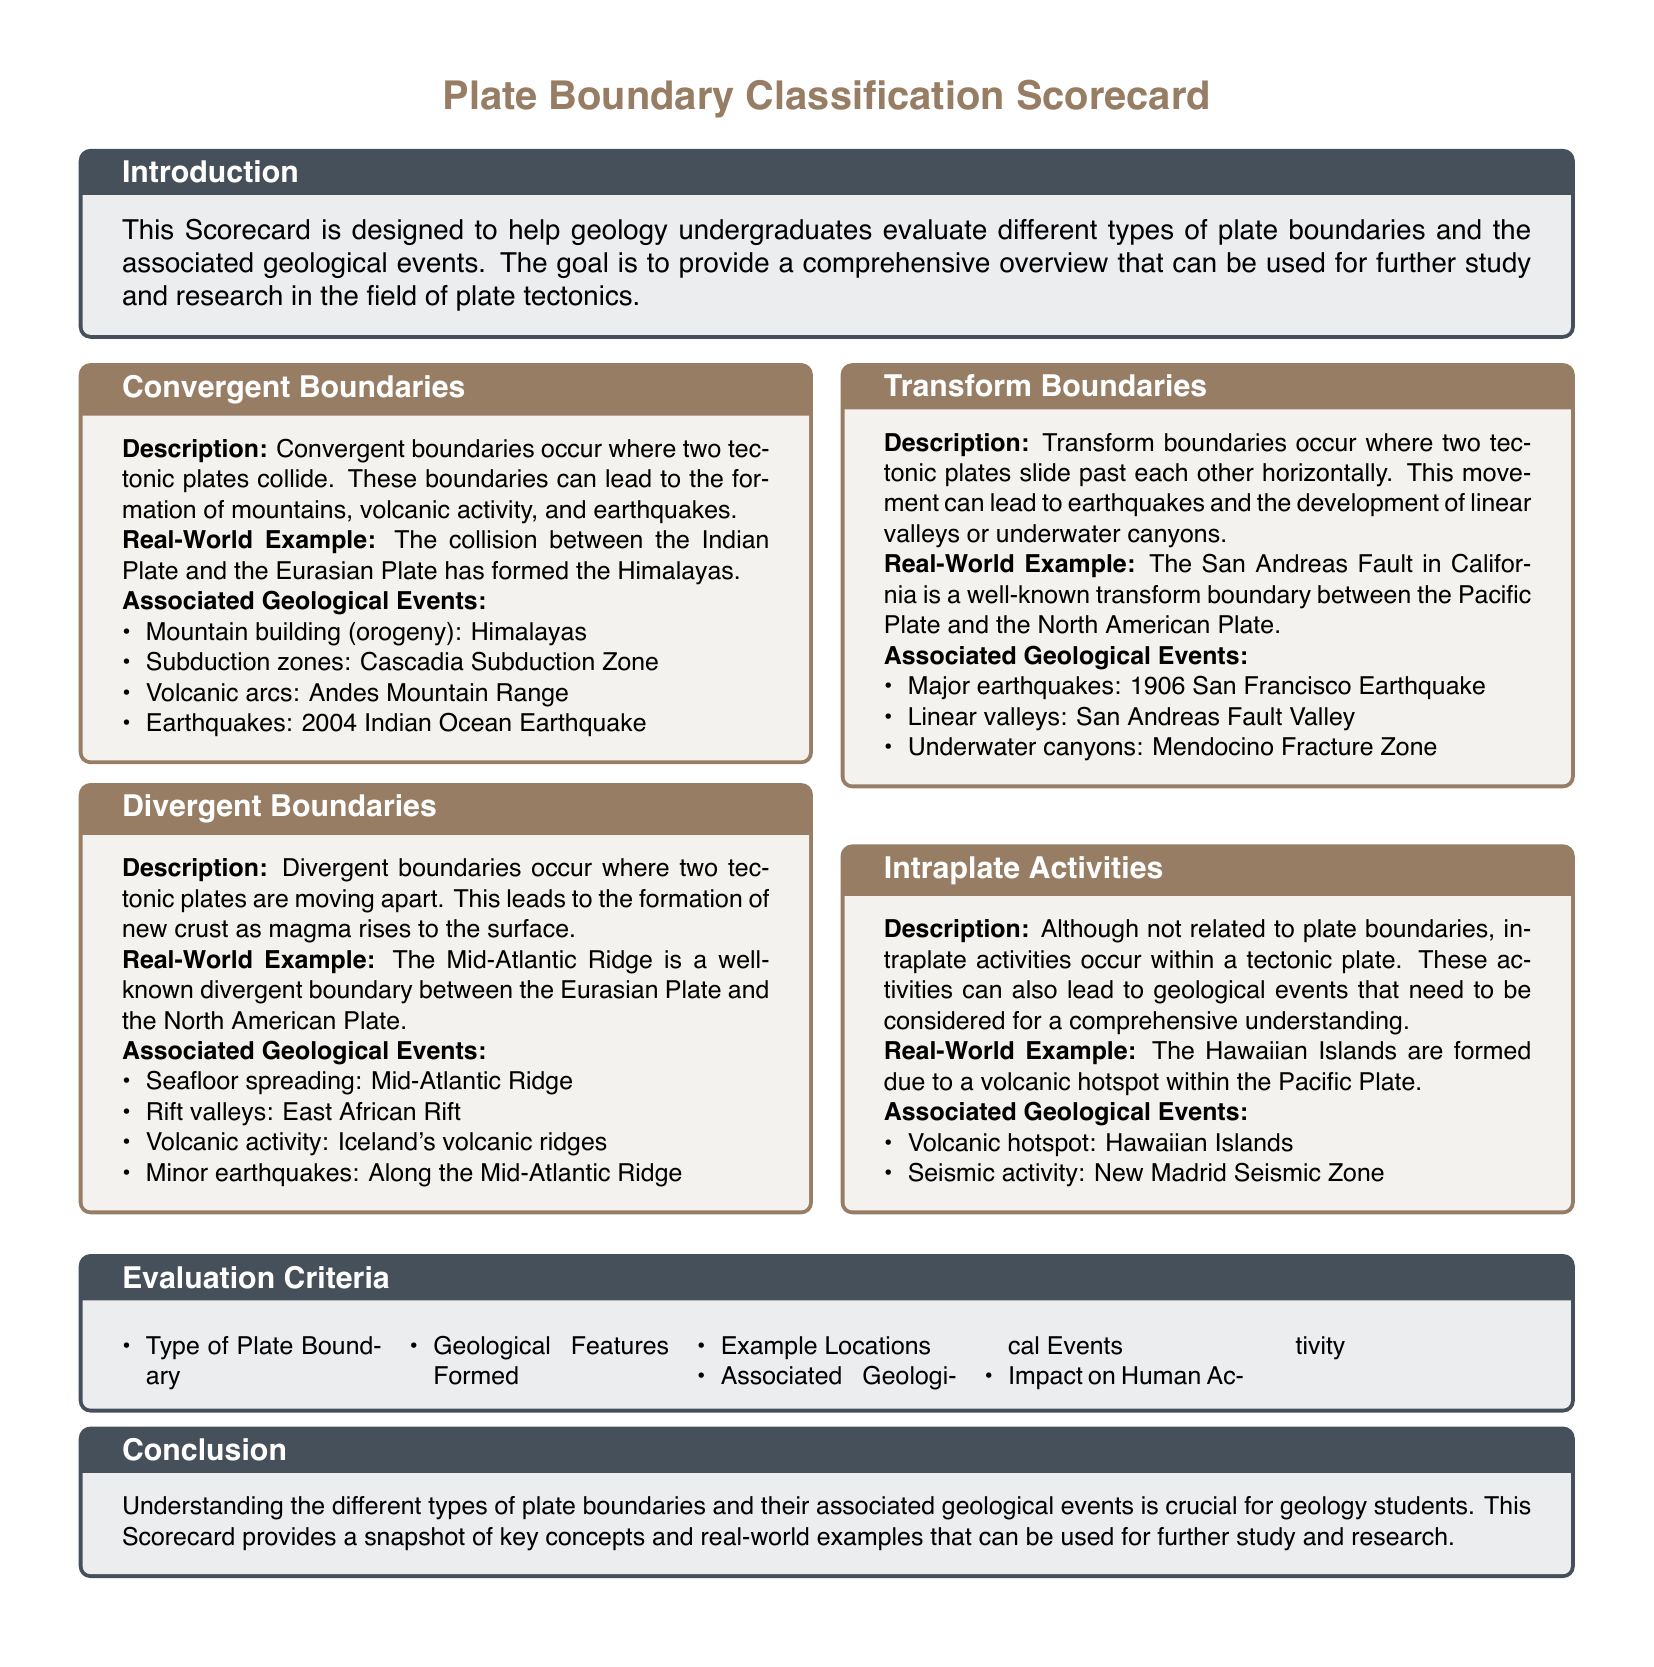What is a real-world example of a convergent boundary? The document provides the collision between the Indian Plate and the Eurasian Plate as an example of a convergent boundary.
Answer: Himalayas What type of boundary is the San Andreas Fault? The document categorizes the San Andreas Fault as a transform boundary.
Answer: Transform Boundary What geological event is associated with divergent boundaries? The document lists seafloor spreading as an event associated with divergent boundaries.
Answer: Seafloor spreading Name one geological event associated with intraplate activities. The document states that volcanic hotspots, such as those forming the Hawaiian Islands, are associated with intraplate activities.
Answer: Volcanic hotspot What is one impact of transform boundaries on human activity? Though the document does not directly address human activity, it explains associated geological events like major earthquakes.
Answer: Major earthquakes List one criterion for evaluating plate boundaries. The document includes "Type of Plate Boundary" as one of the evaluation criteria.
Answer: Type of Plate Boundary How many different types of plate boundaries are discussed in the document? The document outlines three main types of plate boundaries: Convergent, Divergent, and Transform.
Answer: Three What type of geological feature is formed at divergent boundaries? The document explains that new crust is formed as magma rises at divergent boundaries.
Answer: New crust What natural phenomenon can be observed at convergent boundaries? The document indicates that earthquakes can occur at convergent boundaries.
Answer: Earthquakes 